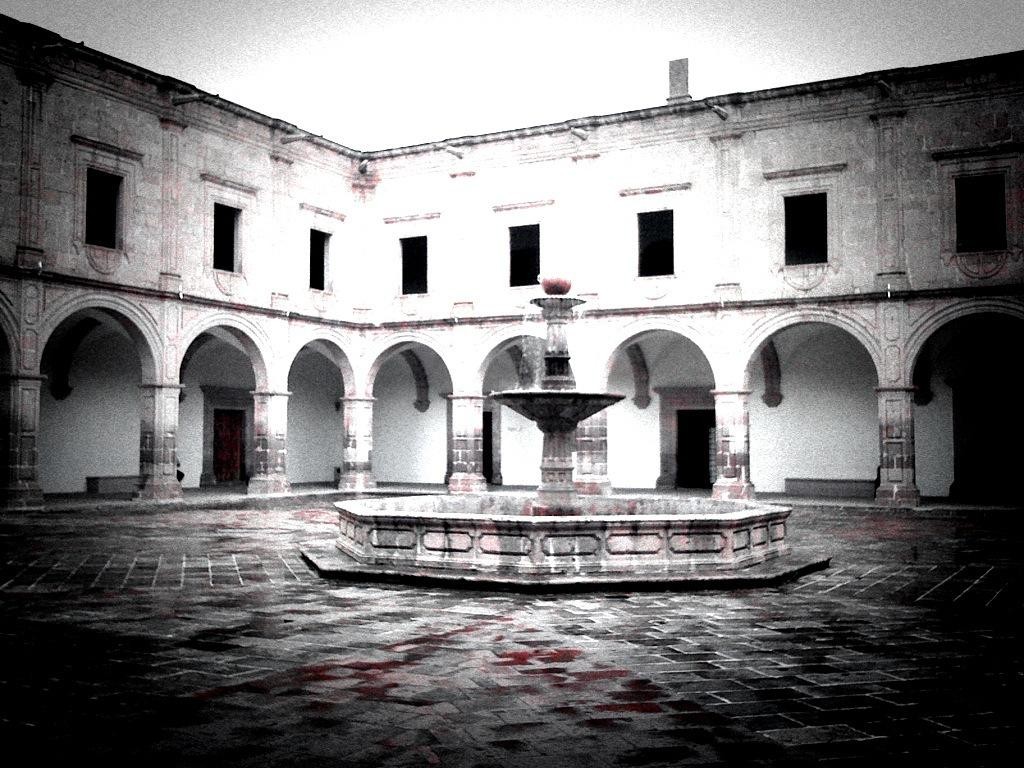What is: What type of space is visible in the image? There is an open area in the image. What feature can be seen in the open area? There is a water fountain in the image. What can be seen in the distance in the image? There is a building in the background of the image. How many lizards are sitting on the basket in the image? There are no lizards or baskets present in the image. What type of suggestion is being made by the person in the image? There is no person in the image, and therefore no suggestion being made. 